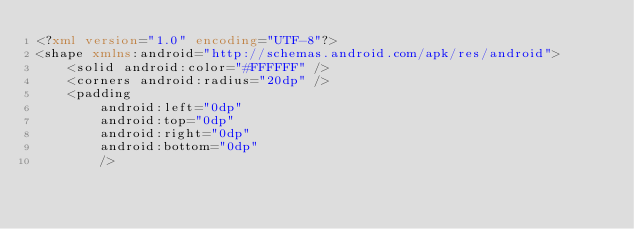Convert code to text. <code><loc_0><loc_0><loc_500><loc_500><_XML_><?xml version="1.0" encoding="UTF-8"?>
<shape xmlns:android="http://schemas.android.com/apk/res/android">
    <solid android:color="#FFFFFF" />
    <corners android:radius="20dp" />
    <padding
        android:left="0dp"
        android:top="0dp"
        android:right="0dp"
        android:bottom="0dp"
        /></code> 